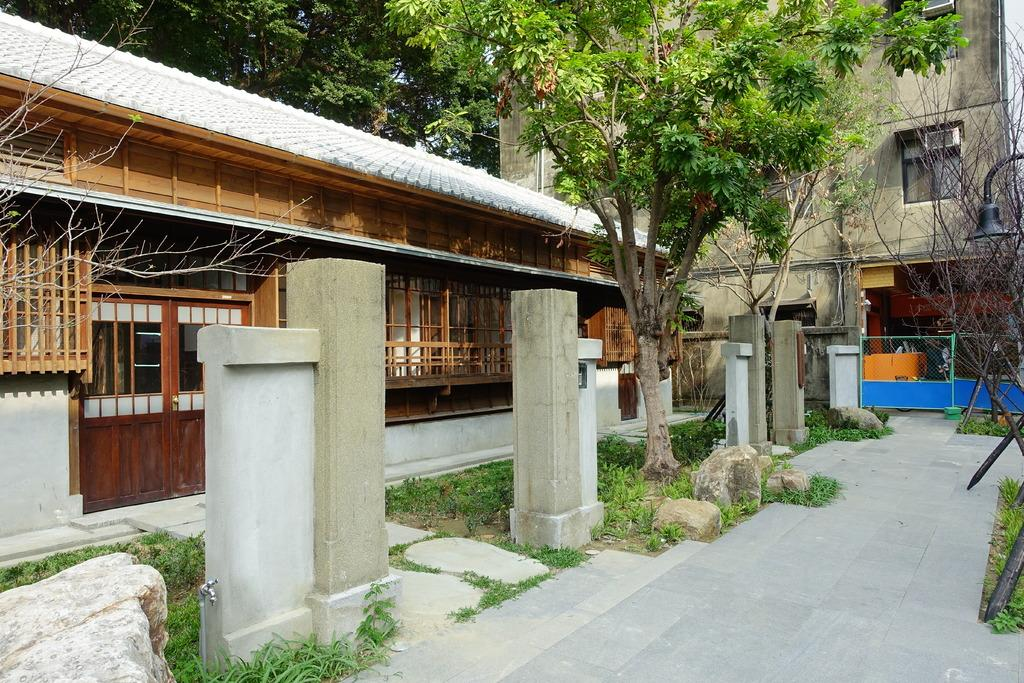What type of natural elements can be seen in the image? There are trees in the image. What type of man-made structures are present in the image? There are buildings in the image. What is located on the right side of the image? There is a blue gate on the right side of the image. What devices can be seen attached to the windows in the image? Air conditioning units (ACs) are attached to the windows. What type of zephyr can be seen blowing through the nation in the image? There is no zephyr or nation present in the image; it features trees, buildings, a blue gate, and ACs attached to windows. 